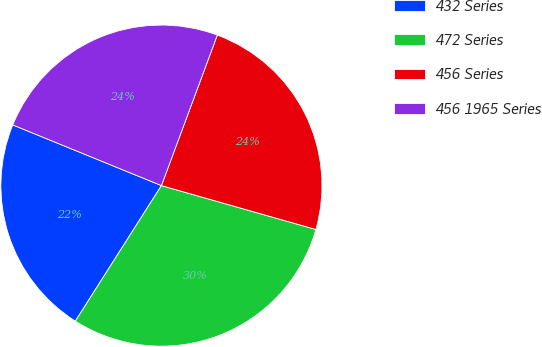Convert chart. <chart><loc_0><loc_0><loc_500><loc_500><pie_chart><fcel>432 Series<fcel>472 Series<fcel>456 Series<fcel>456 1965 Series<nl><fcel>22.16%<fcel>29.6%<fcel>23.75%<fcel>24.49%<nl></chart> 